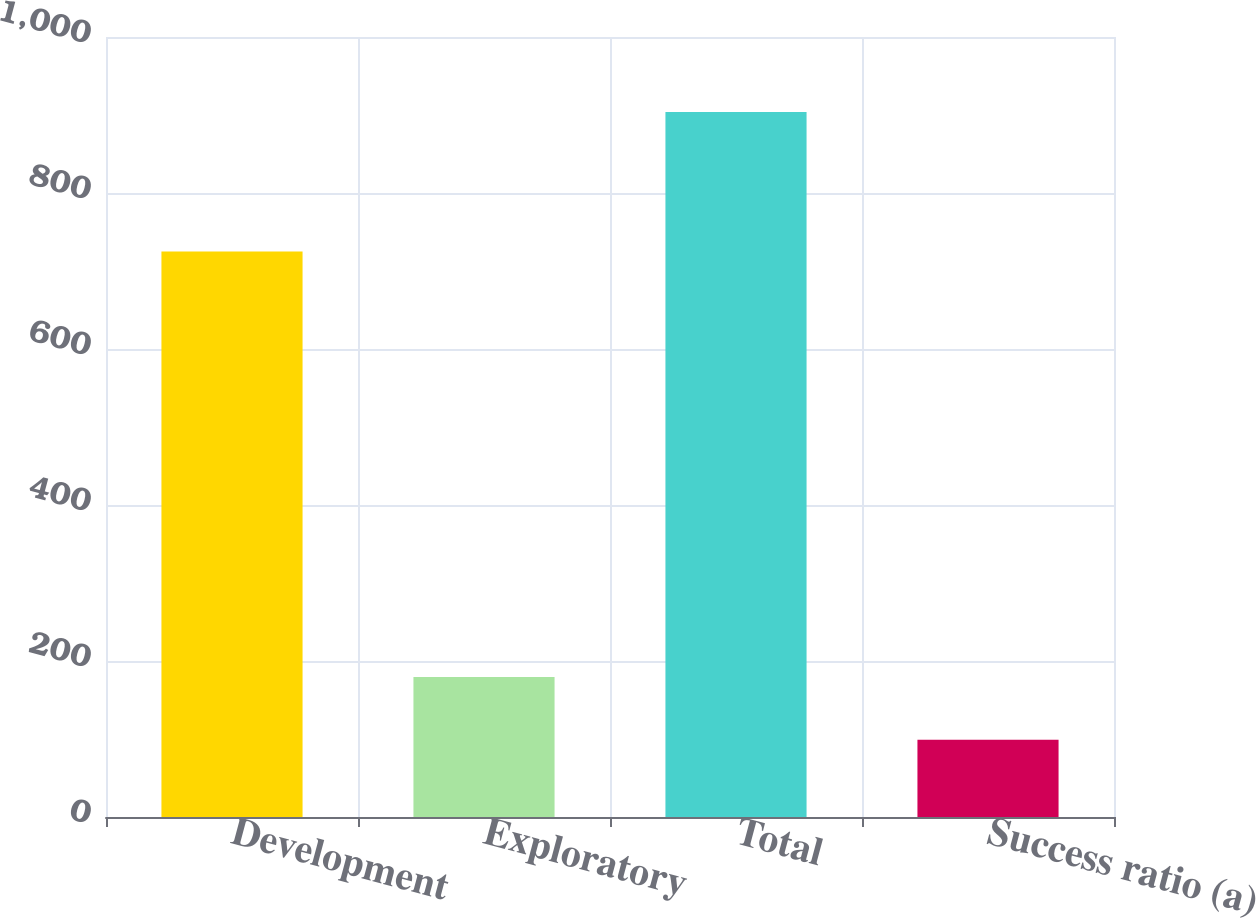<chart> <loc_0><loc_0><loc_500><loc_500><bar_chart><fcel>Development<fcel>Exploratory<fcel>Total<fcel>Success ratio (a)<nl><fcel>725<fcel>179.5<fcel>904<fcel>99<nl></chart> 